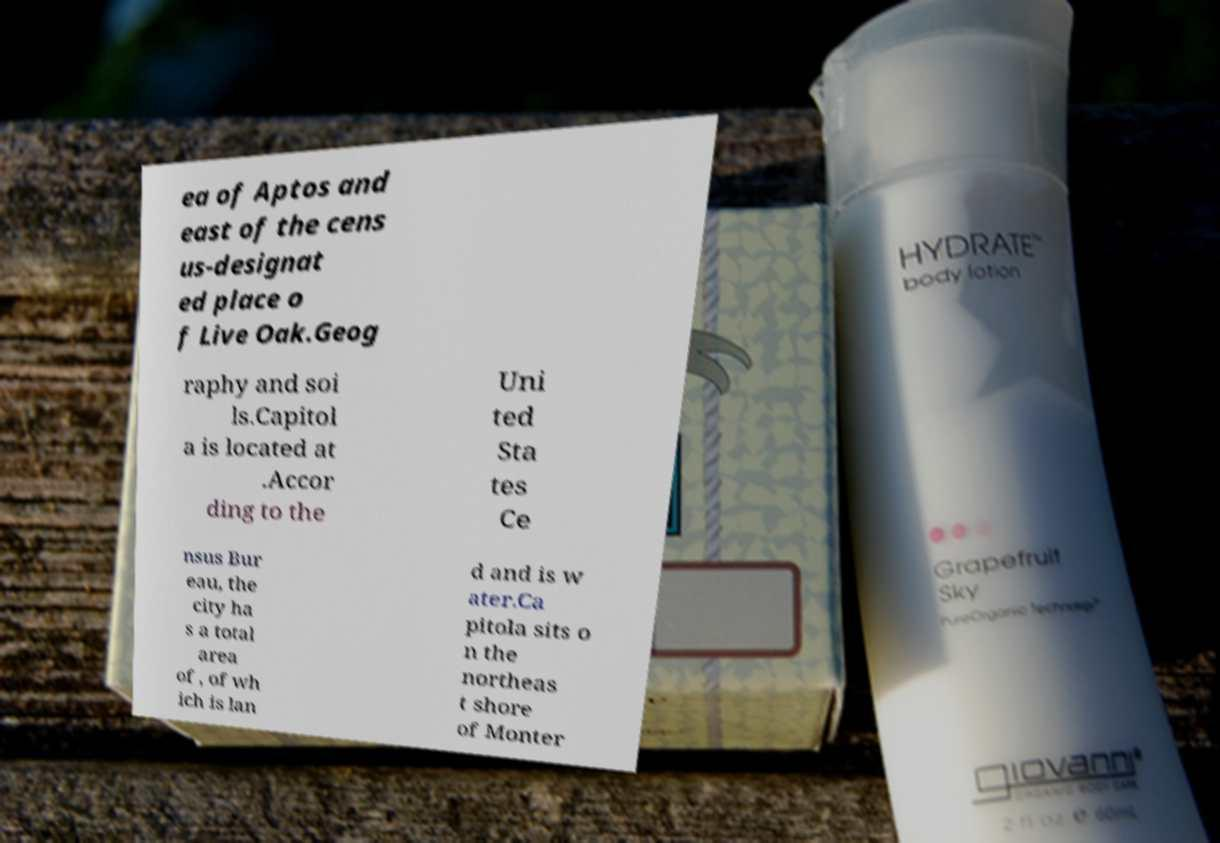I need the written content from this picture converted into text. Can you do that? ea of Aptos and east of the cens us-designat ed place o f Live Oak.Geog raphy and soi ls.Capitol a is located at .Accor ding to the Uni ted Sta tes Ce nsus Bur eau, the city ha s a total area of , of wh ich is lan d and is w ater.Ca pitola sits o n the northeas t shore of Monter 